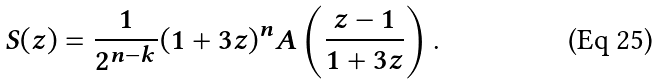<formula> <loc_0><loc_0><loc_500><loc_500>S ( z ) = \frac { 1 } { 2 ^ { n - k } } ( 1 + 3 z ) ^ { n } A \left ( \frac { z - 1 } { 1 + 3 z } \right ) .</formula> 